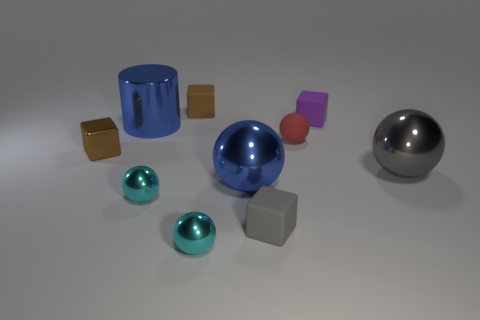Subtract 2 spheres. How many spheres are left? 3 Subtract all gray balls. How many balls are left? 4 Subtract all red balls. How many balls are left? 4 Subtract all brown balls. Subtract all blue blocks. How many balls are left? 5 Subtract all cylinders. How many objects are left? 9 Subtract 0 green spheres. How many objects are left? 10 Subtract all purple rubber things. Subtract all tiny purple objects. How many objects are left? 8 Add 4 small purple things. How many small purple things are left? 5 Add 1 brown objects. How many brown objects exist? 3 